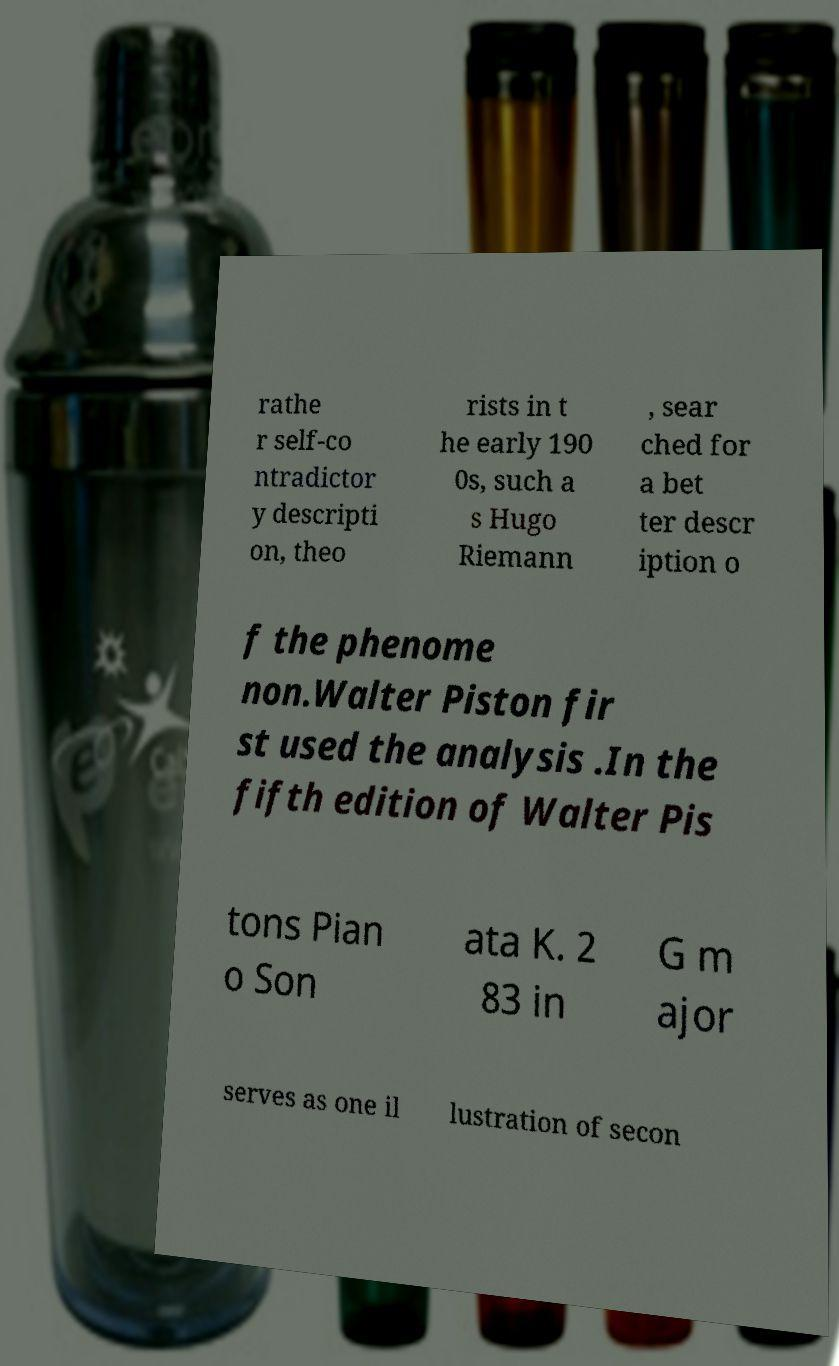Please read and relay the text visible in this image. What does it say? rathe r self-co ntradictor y descripti on, theo rists in t he early 190 0s, such a s Hugo Riemann , sear ched for a bet ter descr iption o f the phenome non.Walter Piston fir st used the analysis .In the fifth edition of Walter Pis tons Pian o Son ata K. 2 83 in G m ajor serves as one il lustration of secon 